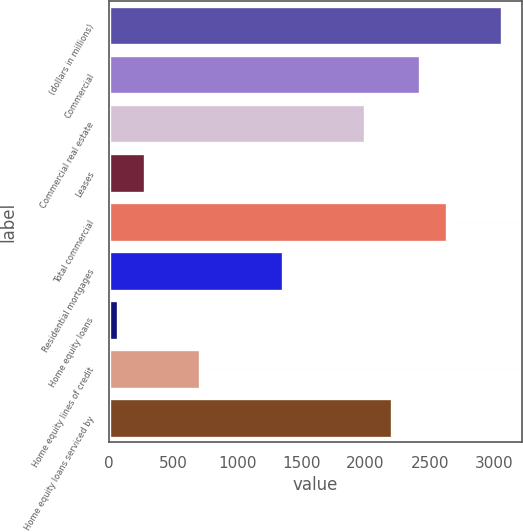Convert chart to OTSL. <chart><loc_0><loc_0><loc_500><loc_500><bar_chart><fcel>(dollars in millions)<fcel>Commercial<fcel>Commercial real estate<fcel>Leases<fcel>Total commercial<fcel>Residential mortgages<fcel>Home equity loans<fcel>Home equity lines of credit<fcel>Home equity loans serviced by<nl><fcel>3065.8<fcel>2423.2<fcel>1994.8<fcel>281.2<fcel>2637.4<fcel>1352.2<fcel>67<fcel>709.6<fcel>2209<nl></chart> 